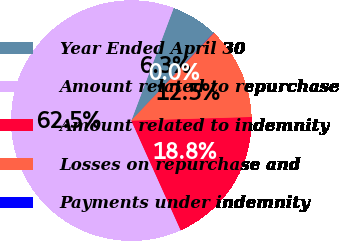Convert chart to OTSL. <chart><loc_0><loc_0><loc_500><loc_500><pie_chart><fcel>Year Ended April 30<fcel>Amount related to repurchase<fcel>Amount related to indemnity<fcel>Losses on repurchase and<fcel>Payments under indemnity<nl><fcel>6.26%<fcel>62.46%<fcel>18.75%<fcel>12.51%<fcel>0.02%<nl></chart> 